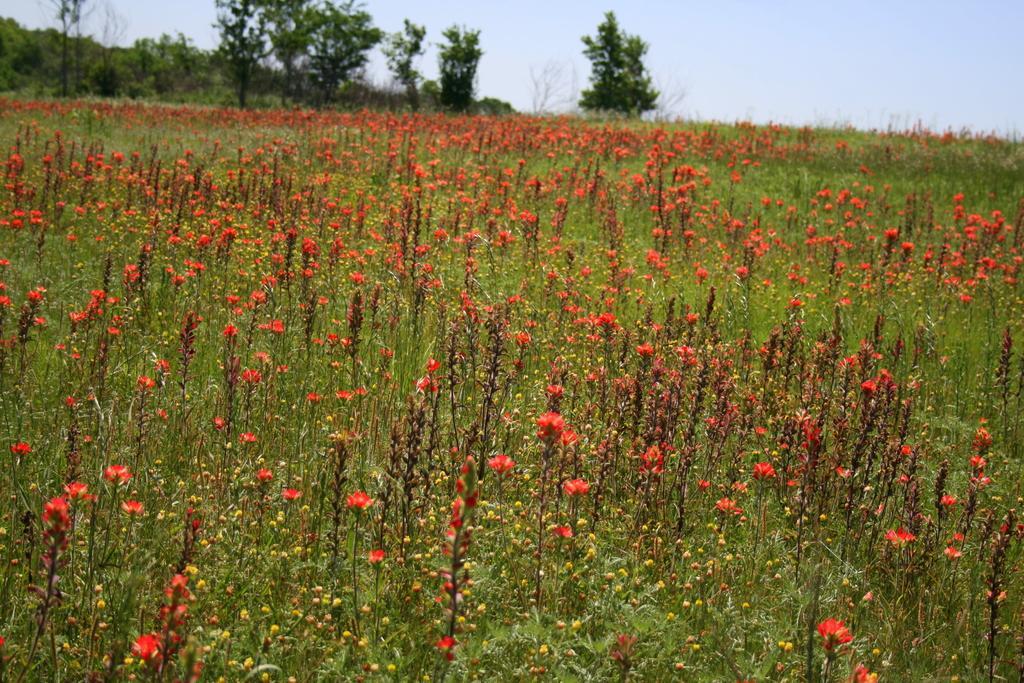In one or two sentences, can you explain what this image depicts? In this picture we can see the plants and flowers. In the background of the image we can see the trees. At the top of the image we can see the sky. 